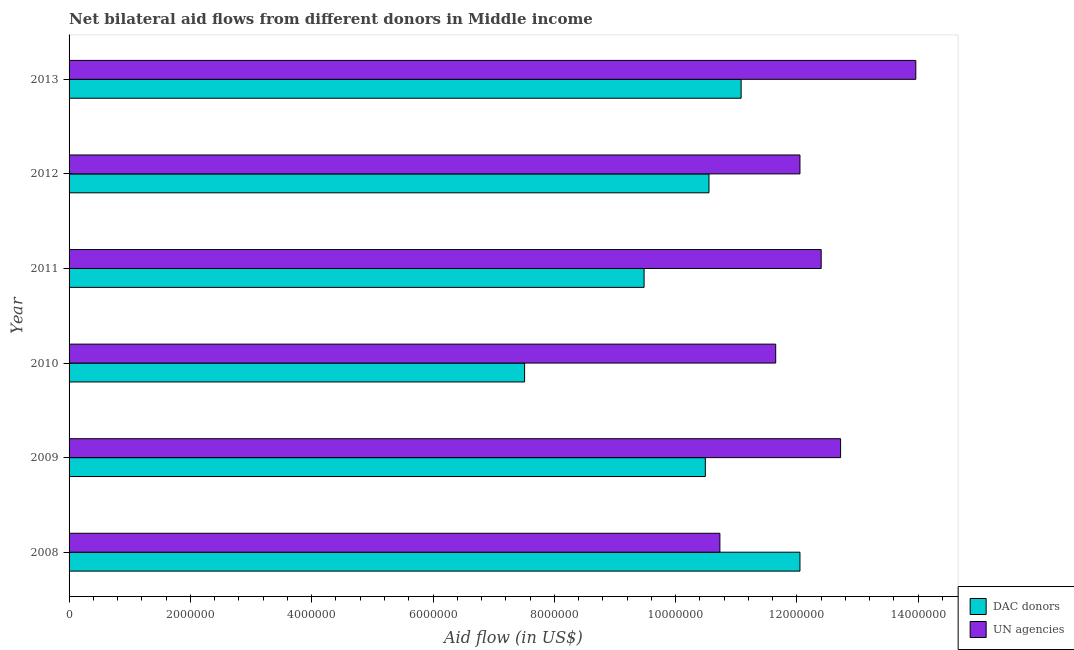How many groups of bars are there?
Ensure brevity in your answer.  6. How many bars are there on the 2nd tick from the bottom?
Keep it short and to the point. 2. In how many cases, is the number of bars for a given year not equal to the number of legend labels?
Your response must be concise. 0. What is the aid flow from dac donors in 2008?
Your response must be concise. 1.20e+07. Across all years, what is the maximum aid flow from dac donors?
Give a very brief answer. 1.20e+07. Across all years, what is the minimum aid flow from dac donors?
Ensure brevity in your answer.  7.51e+06. In which year was the aid flow from un agencies minimum?
Offer a terse response. 2008. What is the total aid flow from dac donors in the graph?
Make the answer very short. 6.12e+07. What is the difference between the aid flow from dac donors in 2008 and that in 2011?
Your answer should be very brief. 2.57e+06. What is the difference between the aid flow from dac donors in 2010 and the aid flow from un agencies in 2013?
Your answer should be compact. -6.45e+06. What is the average aid flow from un agencies per year?
Keep it short and to the point. 1.23e+07. In the year 2013, what is the difference between the aid flow from dac donors and aid flow from un agencies?
Offer a terse response. -2.88e+06. In how many years, is the aid flow from dac donors greater than 1200000 US$?
Give a very brief answer. 6. Is the difference between the aid flow from un agencies in 2010 and 2011 greater than the difference between the aid flow from dac donors in 2010 and 2011?
Provide a short and direct response. Yes. What is the difference between the highest and the second highest aid flow from dac donors?
Make the answer very short. 9.70e+05. What is the difference between the highest and the lowest aid flow from dac donors?
Keep it short and to the point. 4.54e+06. In how many years, is the aid flow from un agencies greater than the average aid flow from un agencies taken over all years?
Your answer should be compact. 3. Is the sum of the aid flow from un agencies in 2011 and 2012 greater than the maximum aid flow from dac donors across all years?
Ensure brevity in your answer.  Yes. What does the 1st bar from the top in 2011 represents?
Ensure brevity in your answer.  UN agencies. What does the 2nd bar from the bottom in 2012 represents?
Your response must be concise. UN agencies. How many bars are there?
Provide a succinct answer. 12. Does the graph contain any zero values?
Your answer should be very brief. No. Where does the legend appear in the graph?
Keep it short and to the point. Bottom right. What is the title of the graph?
Provide a succinct answer. Net bilateral aid flows from different donors in Middle income. What is the label or title of the X-axis?
Offer a terse response. Aid flow (in US$). What is the label or title of the Y-axis?
Keep it short and to the point. Year. What is the Aid flow (in US$) in DAC donors in 2008?
Ensure brevity in your answer.  1.20e+07. What is the Aid flow (in US$) of UN agencies in 2008?
Provide a succinct answer. 1.07e+07. What is the Aid flow (in US$) in DAC donors in 2009?
Offer a very short reply. 1.05e+07. What is the Aid flow (in US$) in UN agencies in 2009?
Your answer should be compact. 1.27e+07. What is the Aid flow (in US$) in DAC donors in 2010?
Ensure brevity in your answer.  7.51e+06. What is the Aid flow (in US$) in UN agencies in 2010?
Provide a short and direct response. 1.16e+07. What is the Aid flow (in US$) of DAC donors in 2011?
Offer a very short reply. 9.48e+06. What is the Aid flow (in US$) of UN agencies in 2011?
Your answer should be compact. 1.24e+07. What is the Aid flow (in US$) of DAC donors in 2012?
Provide a succinct answer. 1.06e+07. What is the Aid flow (in US$) of UN agencies in 2012?
Keep it short and to the point. 1.20e+07. What is the Aid flow (in US$) of DAC donors in 2013?
Your answer should be compact. 1.11e+07. What is the Aid flow (in US$) of UN agencies in 2013?
Provide a short and direct response. 1.40e+07. Across all years, what is the maximum Aid flow (in US$) in DAC donors?
Your answer should be compact. 1.20e+07. Across all years, what is the maximum Aid flow (in US$) of UN agencies?
Your answer should be compact. 1.40e+07. Across all years, what is the minimum Aid flow (in US$) of DAC donors?
Make the answer very short. 7.51e+06. Across all years, what is the minimum Aid flow (in US$) in UN agencies?
Your answer should be compact. 1.07e+07. What is the total Aid flow (in US$) in DAC donors in the graph?
Make the answer very short. 6.12e+07. What is the total Aid flow (in US$) of UN agencies in the graph?
Your answer should be compact. 7.35e+07. What is the difference between the Aid flow (in US$) of DAC donors in 2008 and that in 2009?
Give a very brief answer. 1.56e+06. What is the difference between the Aid flow (in US$) in UN agencies in 2008 and that in 2009?
Provide a short and direct response. -1.99e+06. What is the difference between the Aid flow (in US$) of DAC donors in 2008 and that in 2010?
Your answer should be very brief. 4.54e+06. What is the difference between the Aid flow (in US$) in UN agencies in 2008 and that in 2010?
Make the answer very short. -9.20e+05. What is the difference between the Aid flow (in US$) in DAC donors in 2008 and that in 2011?
Offer a very short reply. 2.57e+06. What is the difference between the Aid flow (in US$) of UN agencies in 2008 and that in 2011?
Keep it short and to the point. -1.67e+06. What is the difference between the Aid flow (in US$) in DAC donors in 2008 and that in 2012?
Ensure brevity in your answer.  1.50e+06. What is the difference between the Aid flow (in US$) of UN agencies in 2008 and that in 2012?
Provide a succinct answer. -1.32e+06. What is the difference between the Aid flow (in US$) of DAC donors in 2008 and that in 2013?
Your answer should be compact. 9.70e+05. What is the difference between the Aid flow (in US$) of UN agencies in 2008 and that in 2013?
Your response must be concise. -3.23e+06. What is the difference between the Aid flow (in US$) in DAC donors in 2009 and that in 2010?
Keep it short and to the point. 2.98e+06. What is the difference between the Aid flow (in US$) in UN agencies in 2009 and that in 2010?
Your answer should be very brief. 1.07e+06. What is the difference between the Aid flow (in US$) in DAC donors in 2009 and that in 2011?
Keep it short and to the point. 1.01e+06. What is the difference between the Aid flow (in US$) of UN agencies in 2009 and that in 2011?
Offer a terse response. 3.20e+05. What is the difference between the Aid flow (in US$) in DAC donors in 2009 and that in 2012?
Ensure brevity in your answer.  -6.00e+04. What is the difference between the Aid flow (in US$) in UN agencies in 2009 and that in 2012?
Provide a short and direct response. 6.70e+05. What is the difference between the Aid flow (in US$) in DAC donors in 2009 and that in 2013?
Ensure brevity in your answer.  -5.90e+05. What is the difference between the Aid flow (in US$) in UN agencies in 2009 and that in 2013?
Give a very brief answer. -1.24e+06. What is the difference between the Aid flow (in US$) in DAC donors in 2010 and that in 2011?
Keep it short and to the point. -1.97e+06. What is the difference between the Aid flow (in US$) of UN agencies in 2010 and that in 2011?
Your answer should be very brief. -7.50e+05. What is the difference between the Aid flow (in US$) in DAC donors in 2010 and that in 2012?
Provide a short and direct response. -3.04e+06. What is the difference between the Aid flow (in US$) of UN agencies in 2010 and that in 2012?
Provide a short and direct response. -4.00e+05. What is the difference between the Aid flow (in US$) in DAC donors in 2010 and that in 2013?
Your answer should be compact. -3.57e+06. What is the difference between the Aid flow (in US$) in UN agencies in 2010 and that in 2013?
Ensure brevity in your answer.  -2.31e+06. What is the difference between the Aid flow (in US$) of DAC donors in 2011 and that in 2012?
Your answer should be very brief. -1.07e+06. What is the difference between the Aid flow (in US$) of UN agencies in 2011 and that in 2012?
Offer a terse response. 3.50e+05. What is the difference between the Aid flow (in US$) of DAC donors in 2011 and that in 2013?
Ensure brevity in your answer.  -1.60e+06. What is the difference between the Aid flow (in US$) in UN agencies in 2011 and that in 2013?
Keep it short and to the point. -1.56e+06. What is the difference between the Aid flow (in US$) of DAC donors in 2012 and that in 2013?
Offer a very short reply. -5.30e+05. What is the difference between the Aid flow (in US$) in UN agencies in 2012 and that in 2013?
Offer a terse response. -1.91e+06. What is the difference between the Aid flow (in US$) of DAC donors in 2008 and the Aid flow (in US$) of UN agencies in 2009?
Keep it short and to the point. -6.70e+05. What is the difference between the Aid flow (in US$) of DAC donors in 2008 and the Aid flow (in US$) of UN agencies in 2010?
Offer a terse response. 4.00e+05. What is the difference between the Aid flow (in US$) in DAC donors in 2008 and the Aid flow (in US$) in UN agencies in 2011?
Ensure brevity in your answer.  -3.50e+05. What is the difference between the Aid flow (in US$) of DAC donors in 2008 and the Aid flow (in US$) of UN agencies in 2013?
Offer a terse response. -1.91e+06. What is the difference between the Aid flow (in US$) of DAC donors in 2009 and the Aid flow (in US$) of UN agencies in 2010?
Offer a very short reply. -1.16e+06. What is the difference between the Aid flow (in US$) of DAC donors in 2009 and the Aid flow (in US$) of UN agencies in 2011?
Your response must be concise. -1.91e+06. What is the difference between the Aid flow (in US$) of DAC donors in 2009 and the Aid flow (in US$) of UN agencies in 2012?
Your answer should be very brief. -1.56e+06. What is the difference between the Aid flow (in US$) in DAC donors in 2009 and the Aid flow (in US$) in UN agencies in 2013?
Your answer should be compact. -3.47e+06. What is the difference between the Aid flow (in US$) in DAC donors in 2010 and the Aid flow (in US$) in UN agencies in 2011?
Your answer should be very brief. -4.89e+06. What is the difference between the Aid flow (in US$) in DAC donors in 2010 and the Aid flow (in US$) in UN agencies in 2012?
Your answer should be compact. -4.54e+06. What is the difference between the Aid flow (in US$) of DAC donors in 2010 and the Aid flow (in US$) of UN agencies in 2013?
Your answer should be compact. -6.45e+06. What is the difference between the Aid flow (in US$) of DAC donors in 2011 and the Aid flow (in US$) of UN agencies in 2012?
Give a very brief answer. -2.57e+06. What is the difference between the Aid flow (in US$) of DAC donors in 2011 and the Aid flow (in US$) of UN agencies in 2013?
Make the answer very short. -4.48e+06. What is the difference between the Aid flow (in US$) of DAC donors in 2012 and the Aid flow (in US$) of UN agencies in 2013?
Your answer should be compact. -3.41e+06. What is the average Aid flow (in US$) of DAC donors per year?
Provide a succinct answer. 1.02e+07. What is the average Aid flow (in US$) in UN agencies per year?
Give a very brief answer. 1.23e+07. In the year 2008, what is the difference between the Aid flow (in US$) in DAC donors and Aid flow (in US$) in UN agencies?
Ensure brevity in your answer.  1.32e+06. In the year 2009, what is the difference between the Aid flow (in US$) of DAC donors and Aid flow (in US$) of UN agencies?
Your response must be concise. -2.23e+06. In the year 2010, what is the difference between the Aid flow (in US$) in DAC donors and Aid flow (in US$) in UN agencies?
Your answer should be compact. -4.14e+06. In the year 2011, what is the difference between the Aid flow (in US$) in DAC donors and Aid flow (in US$) in UN agencies?
Offer a terse response. -2.92e+06. In the year 2012, what is the difference between the Aid flow (in US$) of DAC donors and Aid flow (in US$) of UN agencies?
Make the answer very short. -1.50e+06. In the year 2013, what is the difference between the Aid flow (in US$) of DAC donors and Aid flow (in US$) of UN agencies?
Offer a very short reply. -2.88e+06. What is the ratio of the Aid flow (in US$) in DAC donors in 2008 to that in 2009?
Your answer should be compact. 1.15. What is the ratio of the Aid flow (in US$) of UN agencies in 2008 to that in 2009?
Your answer should be very brief. 0.84. What is the ratio of the Aid flow (in US$) in DAC donors in 2008 to that in 2010?
Ensure brevity in your answer.  1.6. What is the ratio of the Aid flow (in US$) of UN agencies in 2008 to that in 2010?
Ensure brevity in your answer.  0.92. What is the ratio of the Aid flow (in US$) in DAC donors in 2008 to that in 2011?
Give a very brief answer. 1.27. What is the ratio of the Aid flow (in US$) of UN agencies in 2008 to that in 2011?
Make the answer very short. 0.87. What is the ratio of the Aid flow (in US$) of DAC donors in 2008 to that in 2012?
Give a very brief answer. 1.14. What is the ratio of the Aid flow (in US$) of UN agencies in 2008 to that in 2012?
Ensure brevity in your answer.  0.89. What is the ratio of the Aid flow (in US$) of DAC donors in 2008 to that in 2013?
Make the answer very short. 1.09. What is the ratio of the Aid flow (in US$) in UN agencies in 2008 to that in 2013?
Keep it short and to the point. 0.77. What is the ratio of the Aid flow (in US$) in DAC donors in 2009 to that in 2010?
Your answer should be very brief. 1.4. What is the ratio of the Aid flow (in US$) of UN agencies in 2009 to that in 2010?
Offer a terse response. 1.09. What is the ratio of the Aid flow (in US$) of DAC donors in 2009 to that in 2011?
Your answer should be very brief. 1.11. What is the ratio of the Aid flow (in US$) in UN agencies in 2009 to that in 2011?
Your response must be concise. 1.03. What is the ratio of the Aid flow (in US$) in DAC donors in 2009 to that in 2012?
Offer a very short reply. 0.99. What is the ratio of the Aid flow (in US$) in UN agencies in 2009 to that in 2012?
Give a very brief answer. 1.06. What is the ratio of the Aid flow (in US$) in DAC donors in 2009 to that in 2013?
Your response must be concise. 0.95. What is the ratio of the Aid flow (in US$) of UN agencies in 2009 to that in 2013?
Offer a terse response. 0.91. What is the ratio of the Aid flow (in US$) in DAC donors in 2010 to that in 2011?
Provide a short and direct response. 0.79. What is the ratio of the Aid flow (in US$) in UN agencies in 2010 to that in 2011?
Your answer should be very brief. 0.94. What is the ratio of the Aid flow (in US$) of DAC donors in 2010 to that in 2012?
Ensure brevity in your answer.  0.71. What is the ratio of the Aid flow (in US$) of UN agencies in 2010 to that in 2012?
Make the answer very short. 0.97. What is the ratio of the Aid flow (in US$) of DAC donors in 2010 to that in 2013?
Give a very brief answer. 0.68. What is the ratio of the Aid flow (in US$) of UN agencies in 2010 to that in 2013?
Your answer should be compact. 0.83. What is the ratio of the Aid flow (in US$) in DAC donors in 2011 to that in 2012?
Provide a succinct answer. 0.9. What is the ratio of the Aid flow (in US$) in UN agencies in 2011 to that in 2012?
Give a very brief answer. 1.03. What is the ratio of the Aid flow (in US$) of DAC donors in 2011 to that in 2013?
Give a very brief answer. 0.86. What is the ratio of the Aid flow (in US$) of UN agencies in 2011 to that in 2013?
Offer a very short reply. 0.89. What is the ratio of the Aid flow (in US$) in DAC donors in 2012 to that in 2013?
Your answer should be compact. 0.95. What is the ratio of the Aid flow (in US$) of UN agencies in 2012 to that in 2013?
Provide a short and direct response. 0.86. What is the difference between the highest and the second highest Aid flow (in US$) of DAC donors?
Provide a succinct answer. 9.70e+05. What is the difference between the highest and the second highest Aid flow (in US$) of UN agencies?
Provide a succinct answer. 1.24e+06. What is the difference between the highest and the lowest Aid flow (in US$) in DAC donors?
Give a very brief answer. 4.54e+06. What is the difference between the highest and the lowest Aid flow (in US$) of UN agencies?
Make the answer very short. 3.23e+06. 